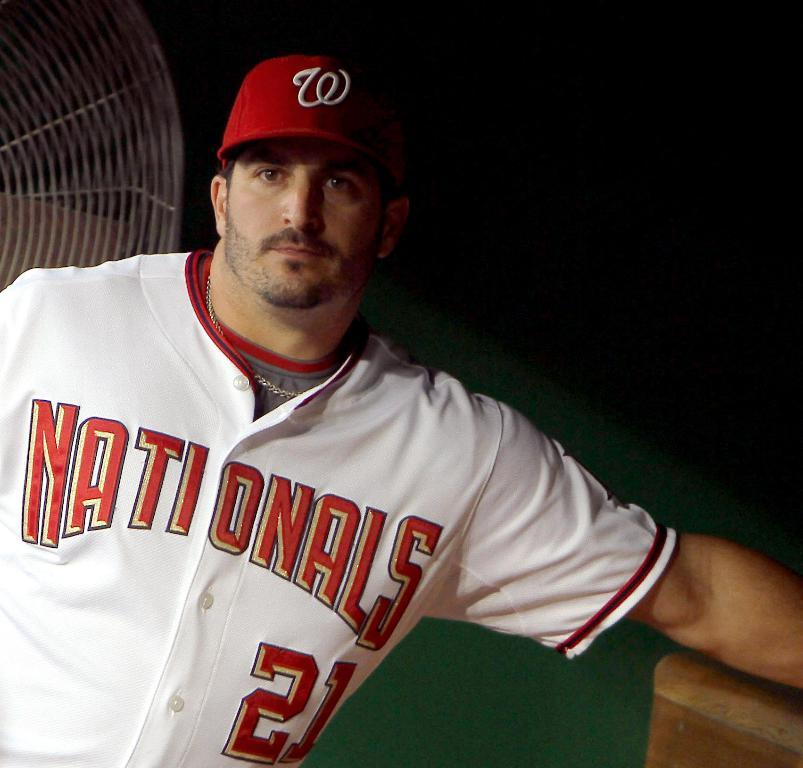<image>
Render a clear and concise summary of the photo. A player with a Nationals jersey on and a red hat 